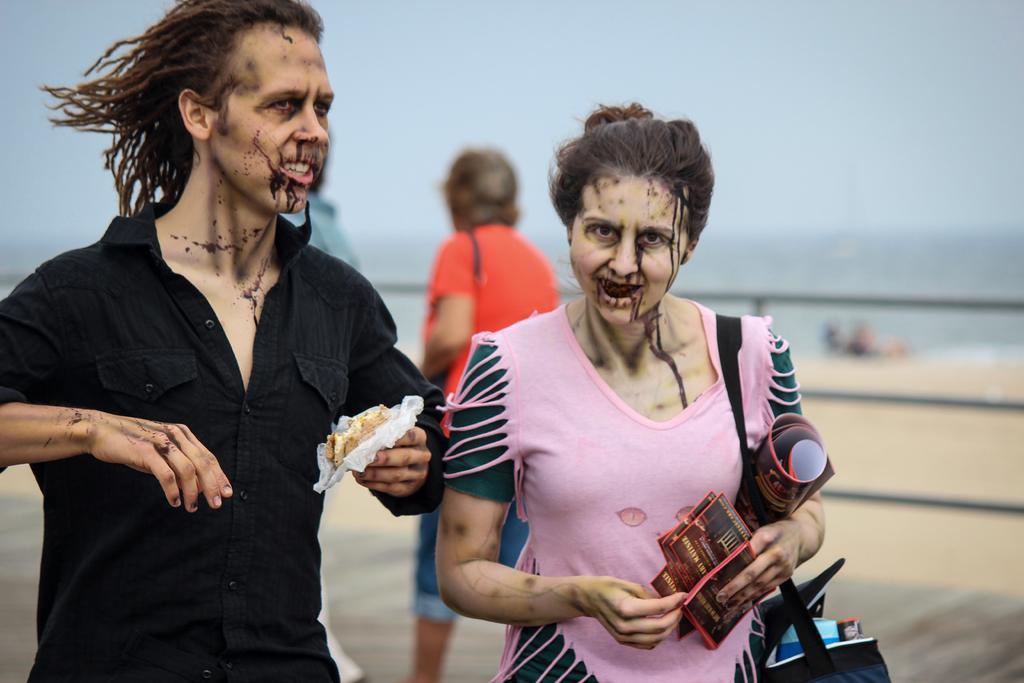Please provide a concise description of this image. In the image there are two people in the foreground, there are some plants to their faces and they are holding some objects with their hands, behind them there is some another person and the background is blurry. 